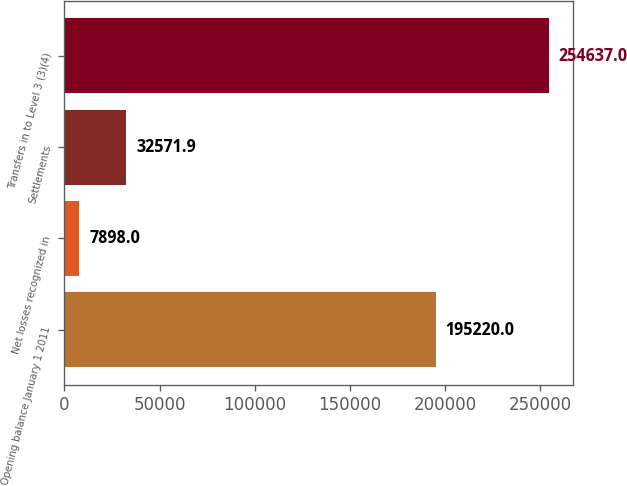Convert chart. <chart><loc_0><loc_0><loc_500><loc_500><bar_chart><fcel>Opening balance January 1 2011<fcel>Net losses recognized in<fcel>Settlements<fcel>Transfers in to Level 3 (3)(4)<nl><fcel>195220<fcel>7898<fcel>32571.9<fcel>254637<nl></chart> 